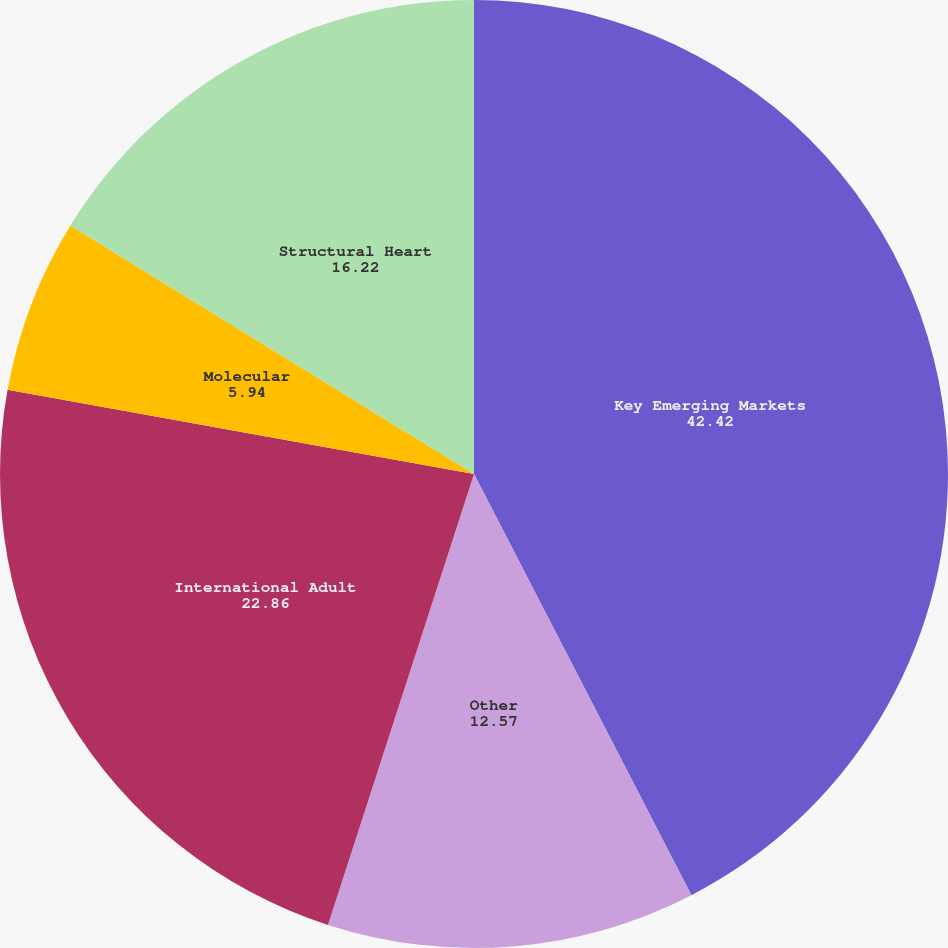<chart> <loc_0><loc_0><loc_500><loc_500><pie_chart><fcel>Key Emerging Markets<fcel>Other<fcel>International Adult<fcel>Molecular<fcel>Structural Heart<nl><fcel>42.42%<fcel>12.57%<fcel>22.86%<fcel>5.94%<fcel>16.22%<nl></chart> 